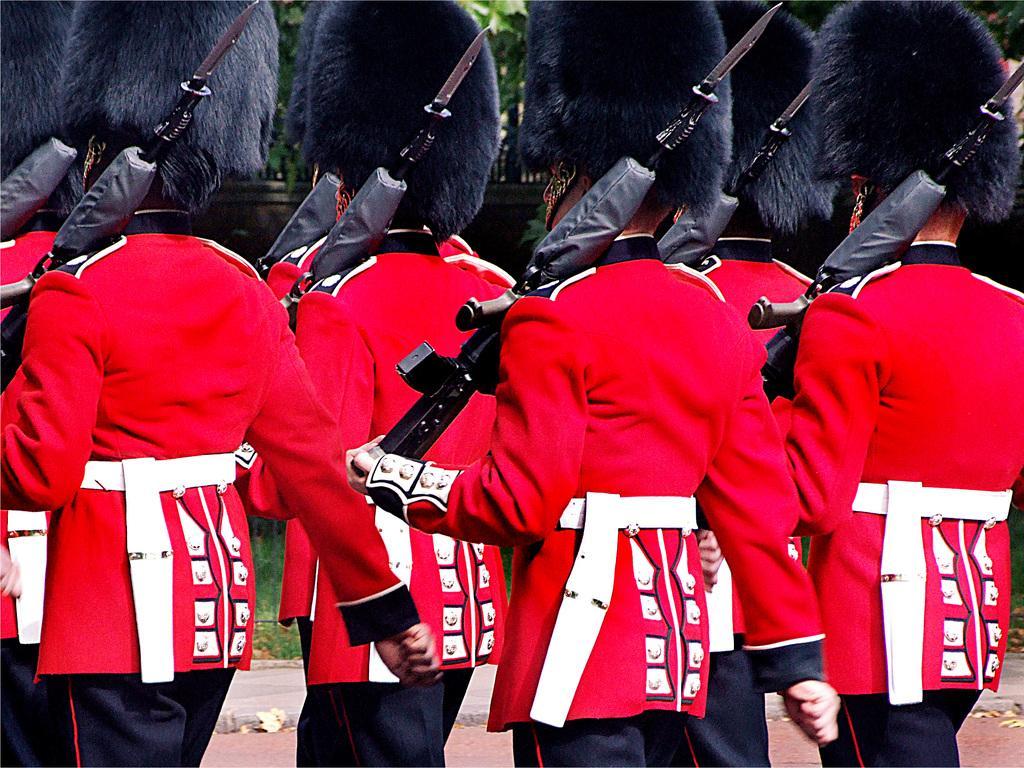Please provide a concise description of this image. In this image we can see a group of people standing holding the guns. On the backside we can see a wall and some trees. 